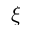Convert formula to latex. <formula><loc_0><loc_0><loc_500><loc_500>\xi</formula> 